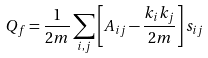<formula> <loc_0><loc_0><loc_500><loc_500>Q _ { f } = \frac { 1 } { 2 m } \sum _ { i , j } \left [ A _ { i j } - \frac { k _ { i } k _ { j } } { 2 m } \right ] s _ { i j }</formula> 